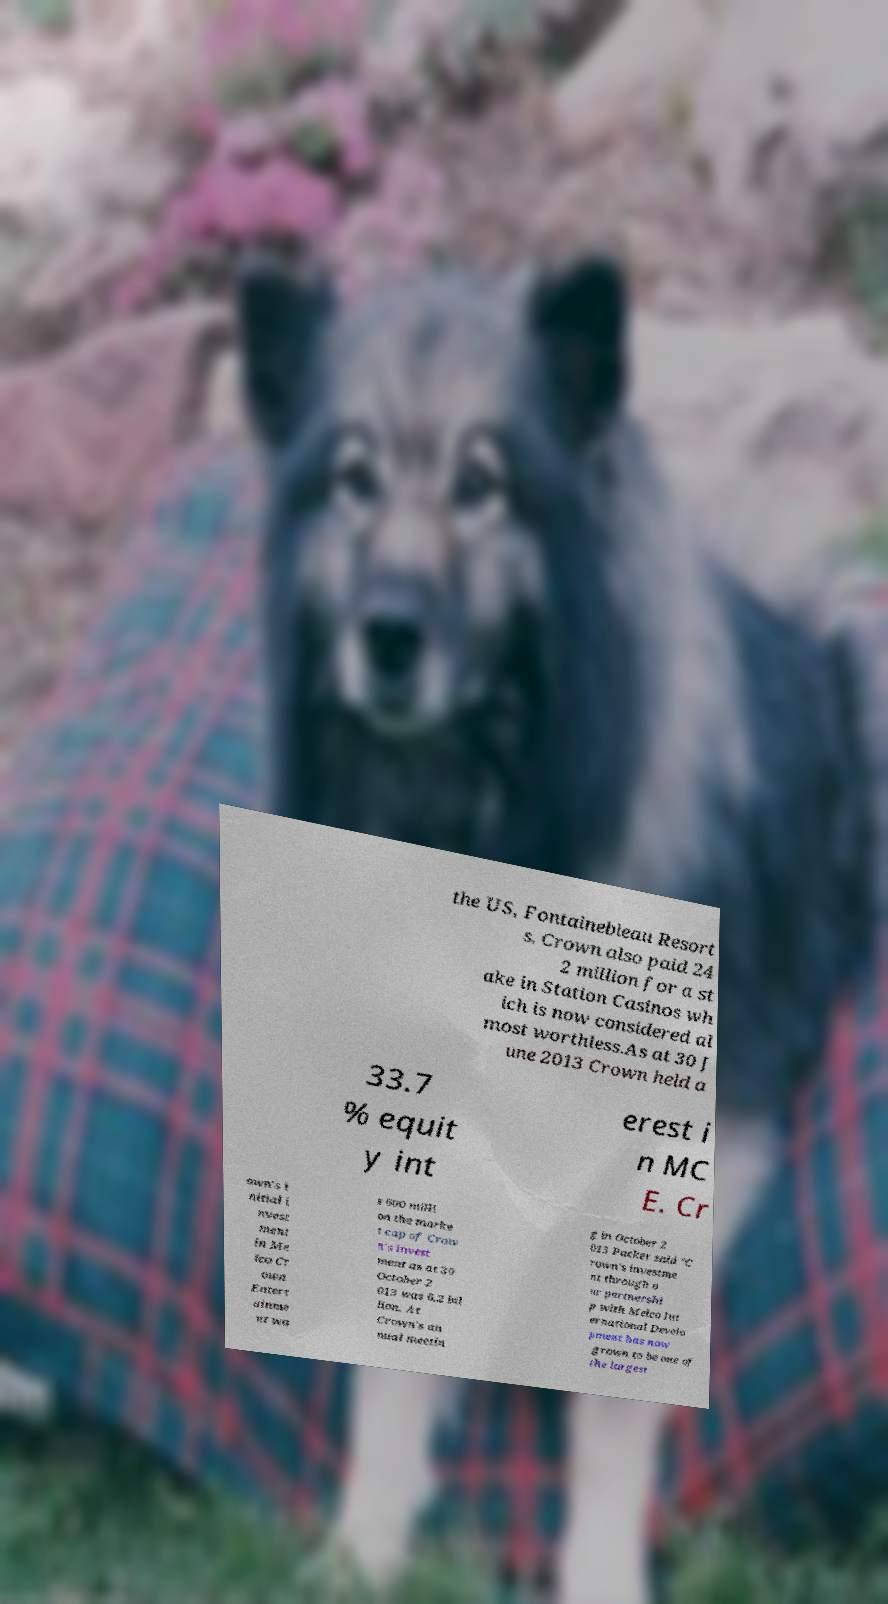There's text embedded in this image that I need extracted. Can you transcribe it verbatim? the US, Fontainebleau Resort s. Crown also paid 24 2 million for a st ake in Station Casinos wh ich is now considered al most worthless.As at 30 J une 2013 Crown held a 33.7 % equit y int erest i n MC E. Cr own's i nitial i nvest ment in Me lco Cr own Entert ainme nt wa s 600 milli on the marke t cap of Crow n's invest ment as at 30 October 2 013 was 6.2 bil lion. At Crown's an nual meetin g in October 2 013 Packer said "C rown's investme nt through o ur partnershi p with Melco Int ernational Develo pment has now grown to be one of the largest 